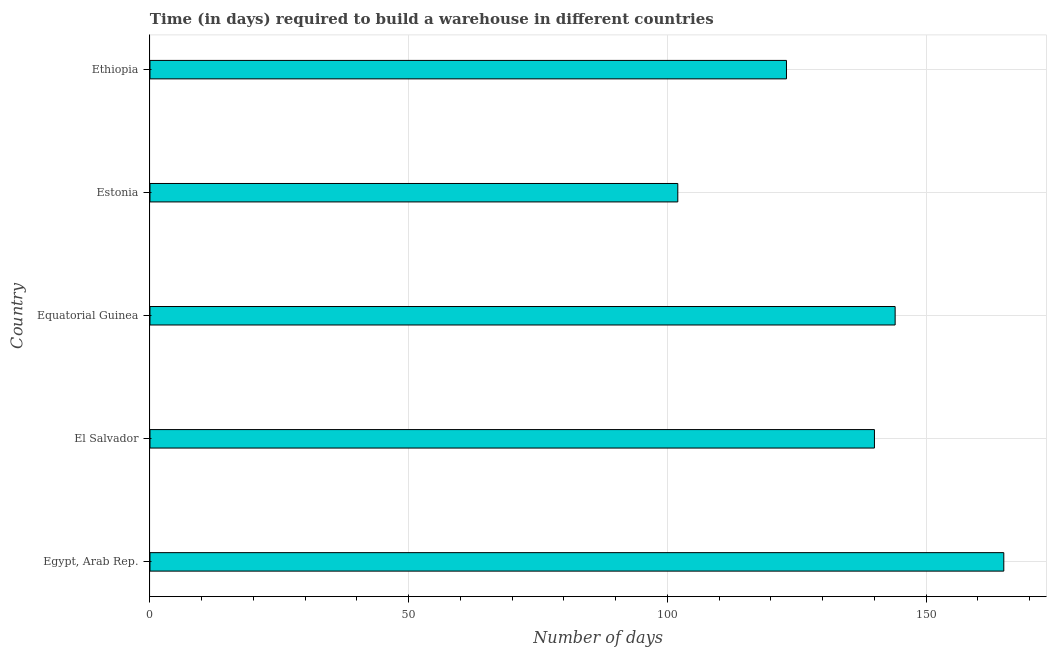What is the title of the graph?
Provide a short and direct response. Time (in days) required to build a warehouse in different countries. What is the label or title of the X-axis?
Your response must be concise. Number of days. What is the time required to build a warehouse in Egypt, Arab Rep.?
Your answer should be compact. 165. Across all countries, what is the maximum time required to build a warehouse?
Give a very brief answer. 165. Across all countries, what is the minimum time required to build a warehouse?
Keep it short and to the point. 102. In which country was the time required to build a warehouse maximum?
Offer a terse response. Egypt, Arab Rep. In which country was the time required to build a warehouse minimum?
Your answer should be compact. Estonia. What is the sum of the time required to build a warehouse?
Offer a very short reply. 674. What is the difference between the time required to build a warehouse in El Salvador and Equatorial Guinea?
Ensure brevity in your answer.  -4. What is the average time required to build a warehouse per country?
Provide a succinct answer. 134.8. What is the median time required to build a warehouse?
Ensure brevity in your answer.  140. In how many countries, is the time required to build a warehouse greater than 50 days?
Provide a short and direct response. 5. What is the ratio of the time required to build a warehouse in Estonia to that in Ethiopia?
Offer a very short reply. 0.83. What is the difference between the highest and the second highest time required to build a warehouse?
Provide a short and direct response. 21. Is the sum of the time required to build a warehouse in Egypt, Arab Rep. and Equatorial Guinea greater than the maximum time required to build a warehouse across all countries?
Provide a succinct answer. Yes. What is the difference between the highest and the lowest time required to build a warehouse?
Ensure brevity in your answer.  63. How many countries are there in the graph?
Keep it short and to the point. 5. What is the difference between two consecutive major ticks on the X-axis?
Offer a terse response. 50. What is the Number of days of Egypt, Arab Rep.?
Offer a terse response. 165. What is the Number of days in El Salvador?
Ensure brevity in your answer.  140. What is the Number of days of Equatorial Guinea?
Provide a short and direct response. 144. What is the Number of days of Estonia?
Provide a short and direct response. 102. What is the Number of days of Ethiopia?
Provide a short and direct response. 123. What is the difference between the Number of days in Egypt, Arab Rep. and El Salvador?
Your answer should be compact. 25. What is the difference between the Number of days in Egypt, Arab Rep. and Estonia?
Offer a terse response. 63. What is the difference between the Number of days in Egypt, Arab Rep. and Ethiopia?
Keep it short and to the point. 42. What is the difference between the Number of days in El Salvador and Estonia?
Make the answer very short. 38. What is the difference between the Number of days in Equatorial Guinea and Ethiopia?
Provide a short and direct response. 21. What is the ratio of the Number of days in Egypt, Arab Rep. to that in El Salvador?
Offer a terse response. 1.18. What is the ratio of the Number of days in Egypt, Arab Rep. to that in Equatorial Guinea?
Give a very brief answer. 1.15. What is the ratio of the Number of days in Egypt, Arab Rep. to that in Estonia?
Keep it short and to the point. 1.62. What is the ratio of the Number of days in Egypt, Arab Rep. to that in Ethiopia?
Your answer should be very brief. 1.34. What is the ratio of the Number of days in El Salvador to that in Equatorial Guinea?
Your response must be concise. 0.97. What is the ratio of the Number of days in El Salvador to that in Estonia?
Offer a terse response. 1.37. What is the ratio of the Number of days in El Salvador to that in Ethiopia?
Keep it short and to the point. 1.14. What is the ratio of the Number of days in Equatorial Guinea to that in Estonia?
Make the answer very short. 1.41. What is the ratio of the Number of days in Equatorial Guinea to that in Ethiopia?
Your response must be concise. 1.17. What is the ratio of the Number of days in Estonia to that in Ethiopia?
Make the answer very short. 0.83. 